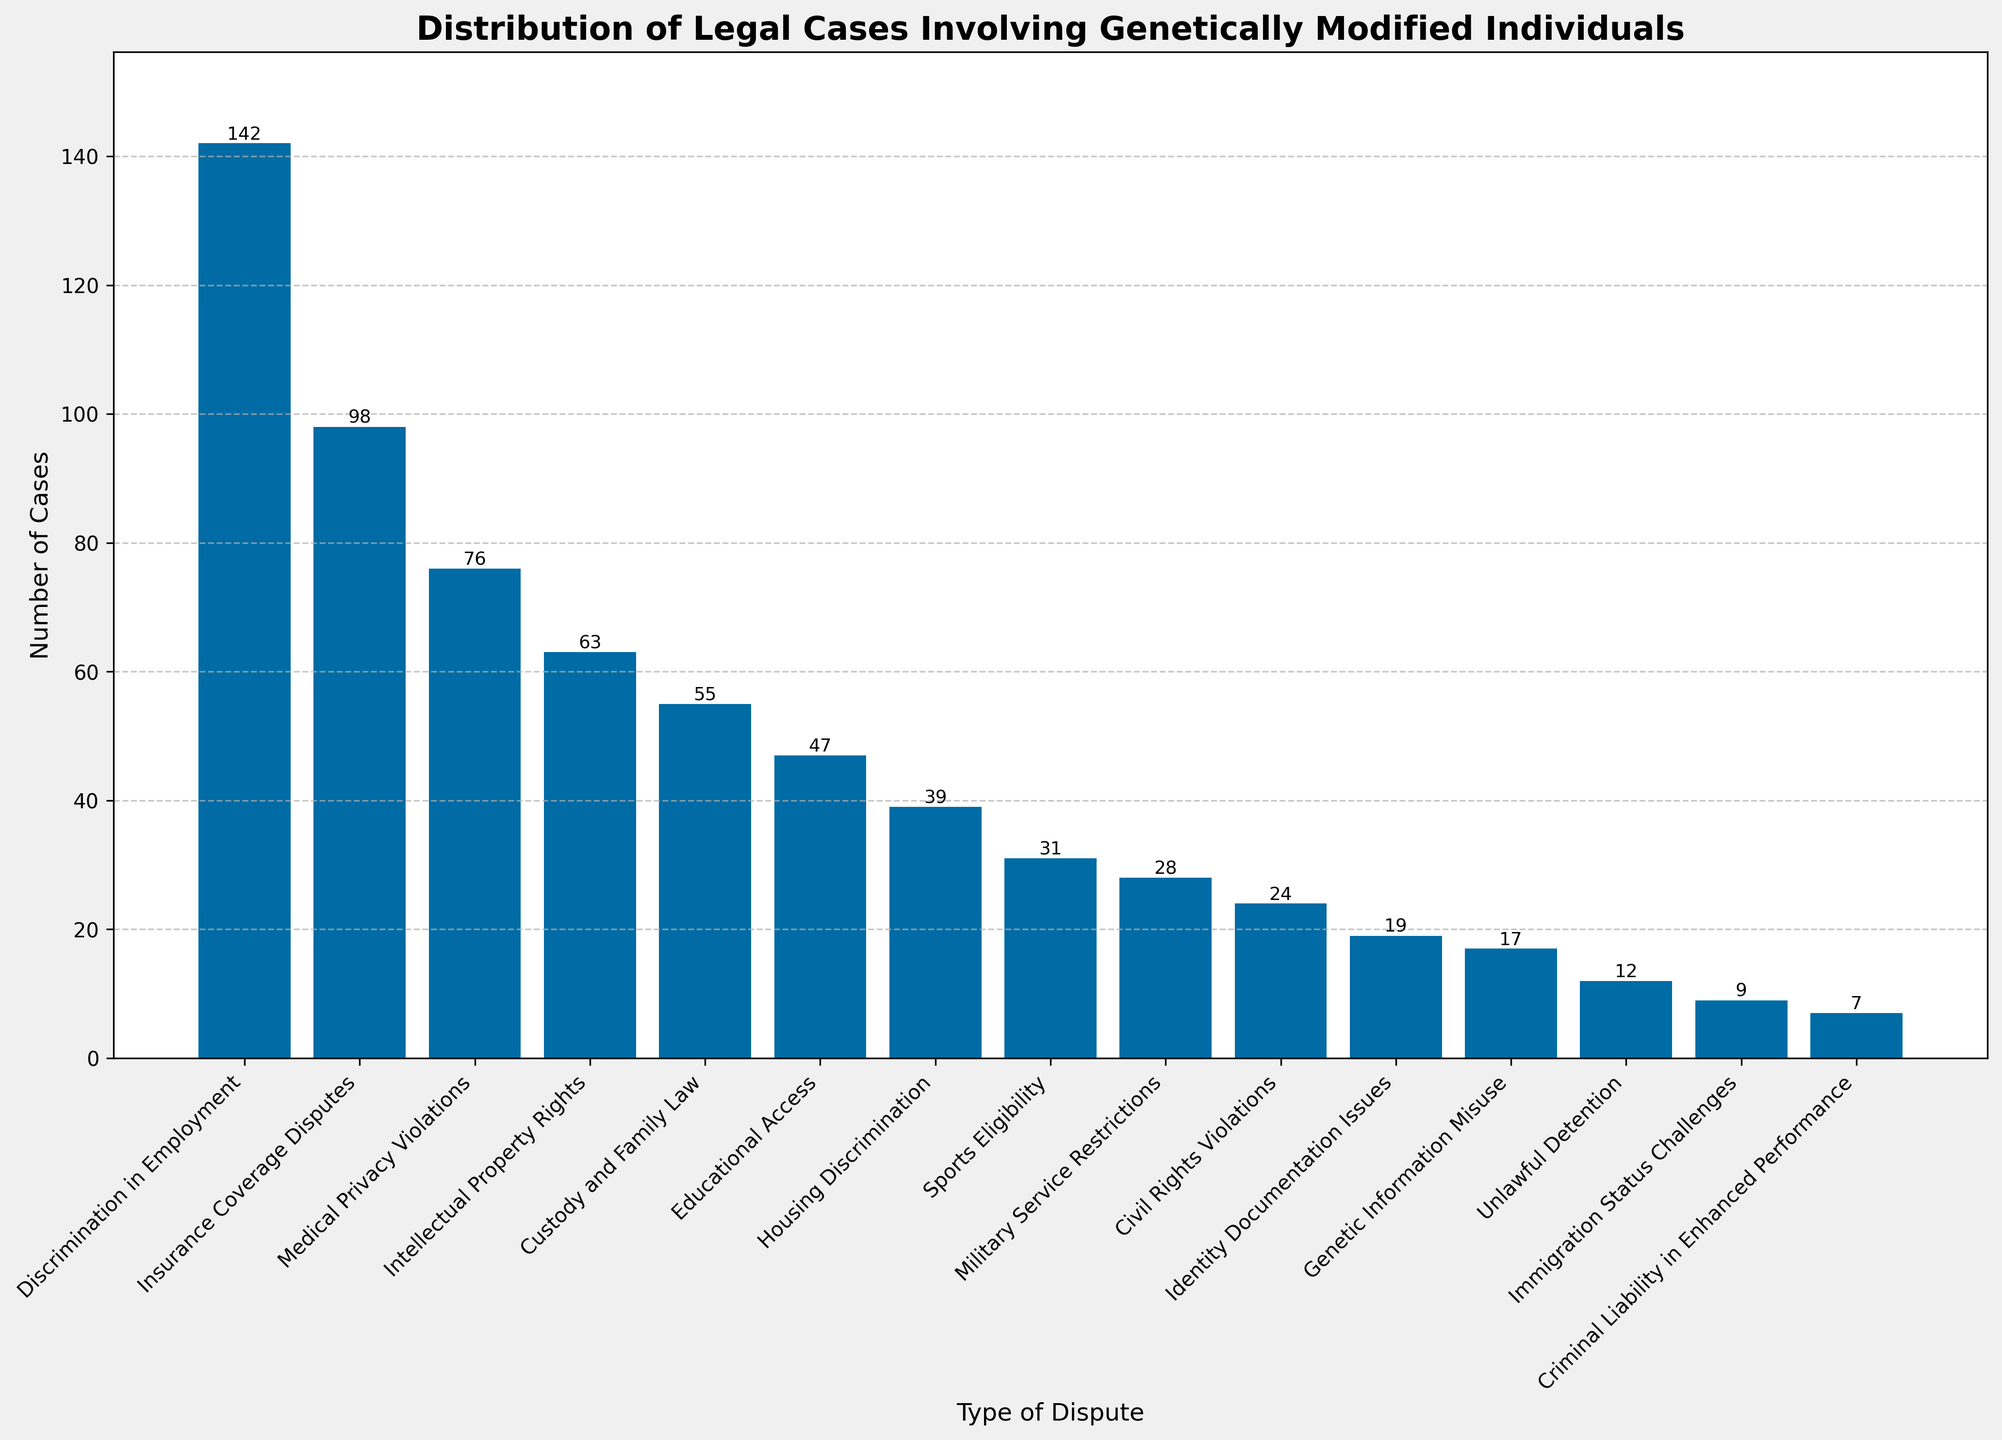what type of dispute has the highest number of cases? By examining the height of the bars, the bar for "Discrimination in Employment" is the tallest, indicating the highest number of cases.
Answer: Discrimination in Employment Which two types of disputes combined have a total of just over 200 cases? From the figure, "Discrimination in Employment" has 142 cases and "Insurance Coverage Disputes" has 98 cases. Summing these (142 + 98) gives 240, which is not just over 200. Next, "Discrimination in Employment" and "Medical Privacy Violations" total to 218 (142 + 76), which is still above. "Discrimination in Employment" with 142 and "Intellectual Property Rights" with 63 gives a total of 205, which is just over 200.
Answer: Discrimination in Employment and Intellectual Property Rights What is the difference in the number of cases between the top and bottom dispute types? "Discrimination in Employment" has the highest number of cases with 142, and "Criminal Liability in Enhanced Performance" has the lowest with 7. The difference is calculated as 142 - 7.
Answer: 135 Which type of dispute has slightly less than half the number of cases compared to "Discrimination in Employment"? "Discrimination in Employment" has 142 cases. Half of 142 is 71. Checking the data, no type of dispute has exactly 71 cases, but "Medical Privacy Violations" has 76 cases which is slightly more than half, but close.
Answer: Medical Privacy Violations Identify a dispute type that has fewer than 50 cases but more than 30 cases. Looking at the bars and their labels, "Educational Access" with 47 cases and "Housing Discrimination" with 39 cases fit the criteria of being more than 30 but fewer than 50 cases.
Answer: Educational Access and Housing Discrimination How many dispute types have fewer than 20 cases? By observing the bars with heights corresponding to fewer than 20 cases, we see "Identity Documentation Issues" (19), "Genetic Information Misuse" (17), "Unlawful Detention" (12), "Immigration Status Challenges" (9), and "Criminal Liability in Enhanced Performance" (7). Counting these bars, we get a total of 5 dispute types.
Answer: 5 What is the cumulative total number of cases for "Sports Eligibility," "Military Service Restrictions," and "Civil Rights Violations"? Summing down the cases for these categories: "Sports Eligibility" has 31, "Military Service Restrictions" has 28, and "Civil Rights Violations" has 24 (31 + 28 + 24).
Answer: 83 Which type of dispute has approximately one-third the number of cases compared to "Discrimination in Employment"? "Discrimination in Employment" has 142 cases. One-third of 142 is approximately 47. Identifying the closest number from the data, "Educational Access" has 47 cases which is exactly one-third.
Answer: Educational Access Is the number of cases for "Insurance Coverage Disputes" greater or less than the combined cases for "Sports Eligibility" and "Military Service Restrictions"? "Insurance Coverage Disputes" has 98 cases. Summing "Sports Eligibility" with 31 and "Military Service Restrictions" with 28 gets 59 (31 + 28). Comparing 98 to 59, 98 is greater.
Answer: Greater 